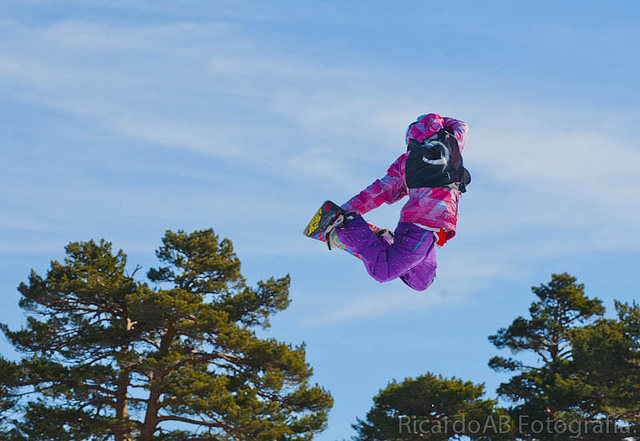Please transcribe the text information in this image. RicardoAB Fotografai 5 